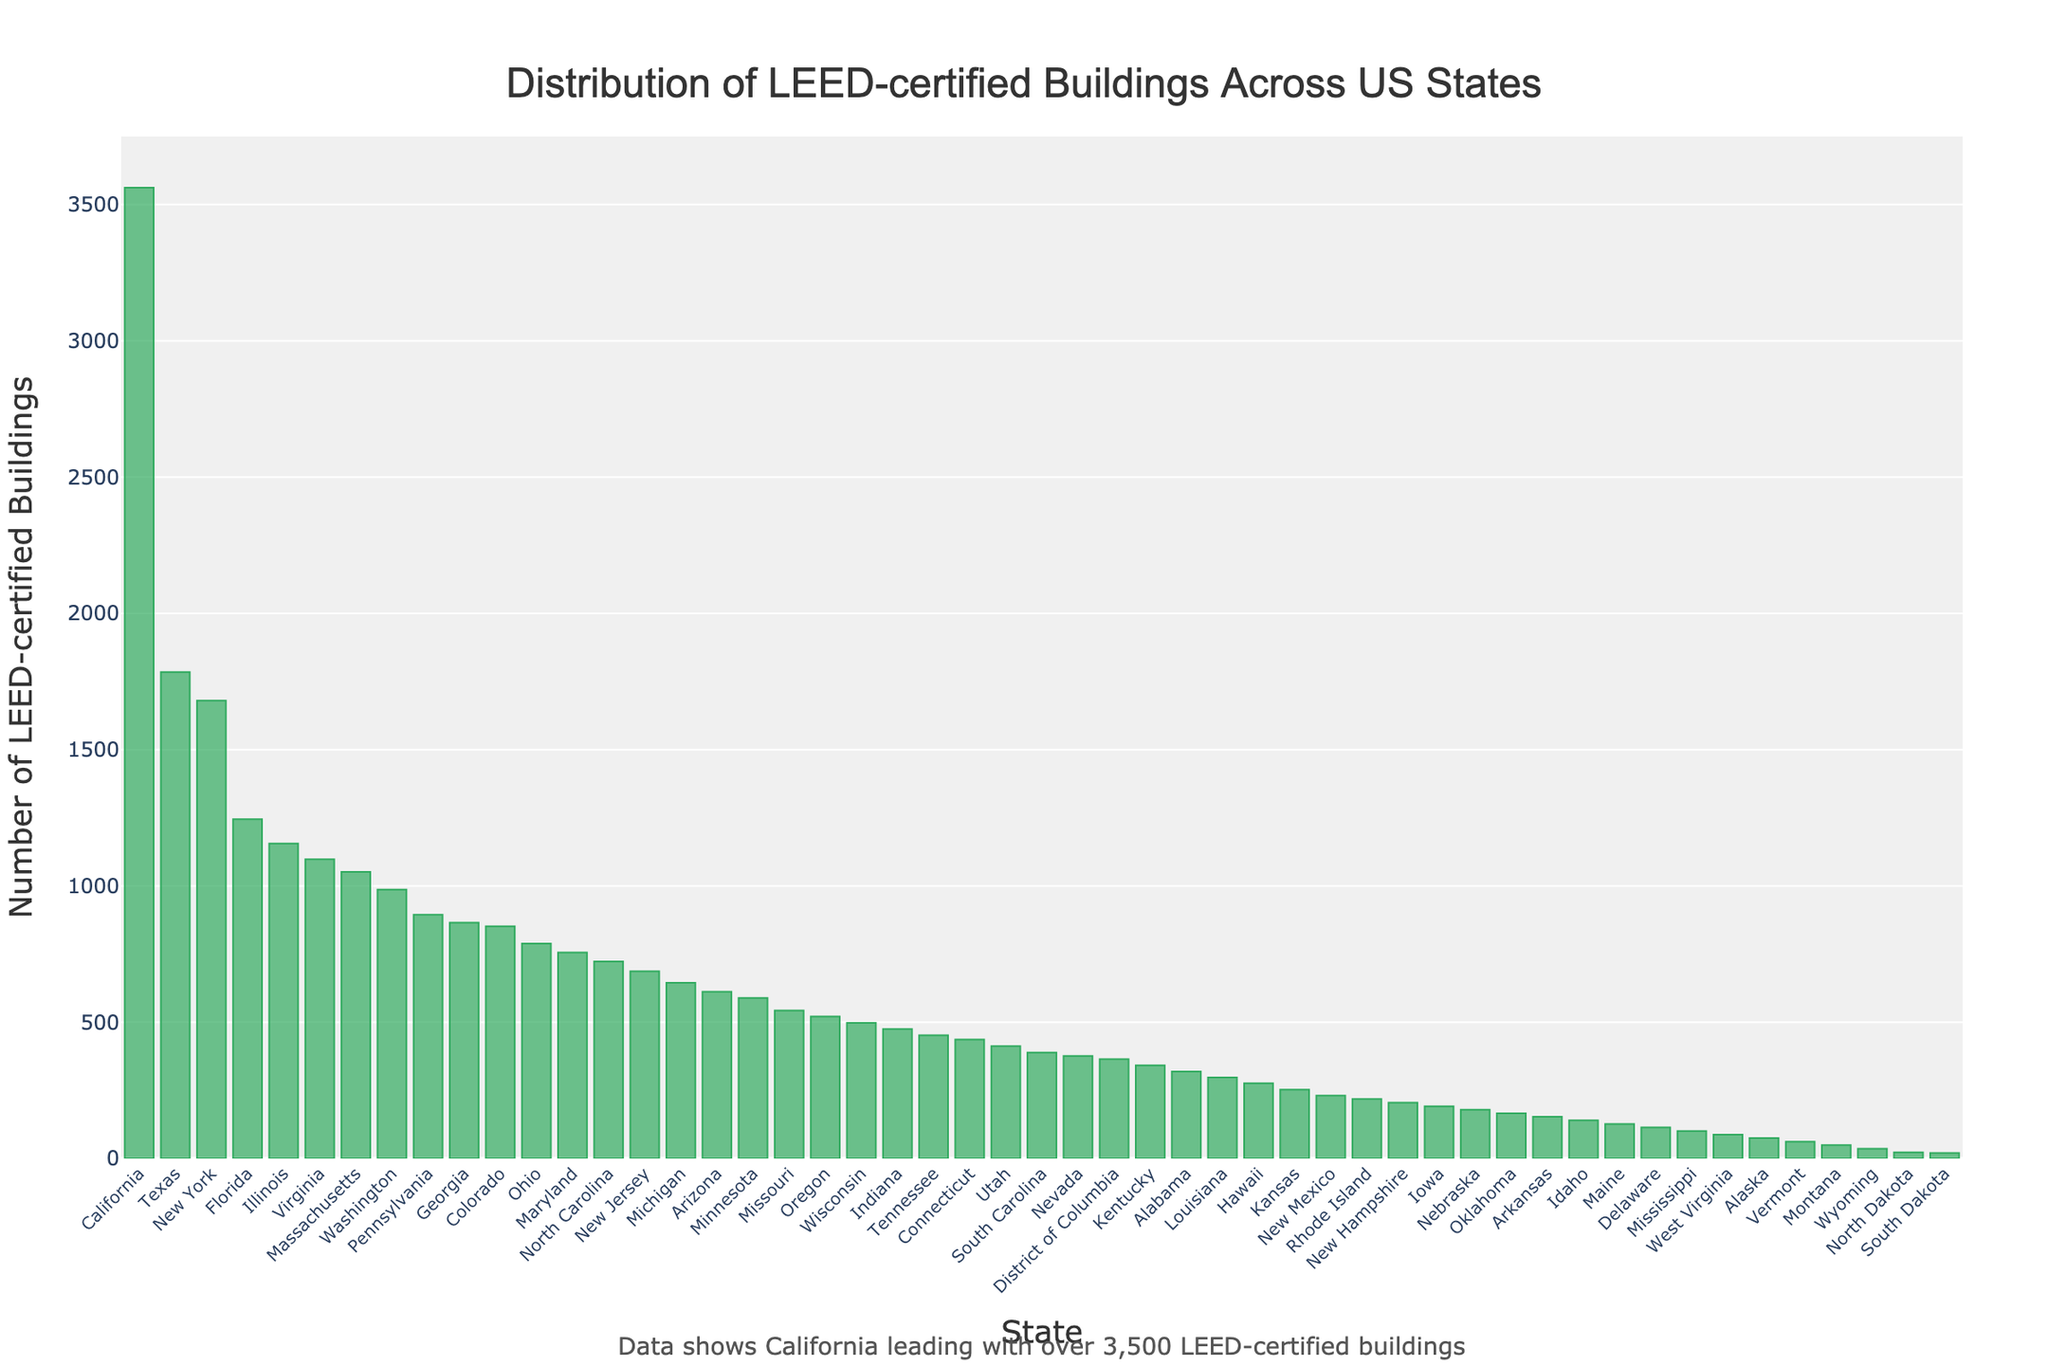Which state has the highest number of LEED-certified buildings? The bar chart shows the number of LEED-certified buildings for each state. By observation, California has the tallest bar, indicating it has the most LEED-certified buildings.
Answer: California Which state has more LEED-certified buildings, New York or Texas? Comparing the heights of the bars for New York and Texas, Texas has a taller bar than New York, which means Texas has more LEED-certified buildings.
Answer: Texas What is the total number of LEED-certified buildings in the top three states? The numbers of LEED-certified buildings in the top three states are: California (3562), Texas (1785), and New York (1680). Summing these values gives 3562 + 1785 + 1680 = 7027.
Answer: 7027 Which state has the least number of LEED-certified buildings, and what is that number? The bar chart shows that Wyoming has the shortest bar, indicating it has the least number of LEED-certified buildings, which is 36.
Answer: Wyoming, 36 How many states have over 1000 LEED-certified buildings? Counting the states with bars representing over 1000 LEED-certified buildings are: California, Texas, New York, Florida, Illinois, Virginia, Massachusetts, and Washington. This gives a total of 8 states.
Answer: 8 Which state has more LEED-certified buildings, Oregon or Pennsylvania? By observing the heights of the bars for Oregon and Pennsylvania, Pennsylvania has a taller bar than Oregon, indicating Pennsylvania has more LEED-certified buildings.
Answer: Pennsylvania What is the difference in the number of LEED-certified buildings between Florida and Illinois? The bar chart shows Florida has 1245 LEED-certified buildings, while Illinois has 1156. The difference is 1245 - 1156 = 89.
Answer: 89 How many LEED-certified buildings do Arizona and Colorado have when combined? The bar chart shows Arizona with 612 buildings and Colorado with 852 buildings. Adding these together gives 612 + 852 = 1464.
Answer: 1464 What is the average number of LEED-certified buildings among California, Texas, and New York? Adding the numbers for California (3562), Texas (1785), and New York (1680) gives 3562 + 1785 + 1680 = 7027. Dividing by 3 for the average: 7027 / 3 = 2342.33.
Answer: 2342.33 Is the number of LEED-certified buildings in Indiana greater than or equal to 500? Observing the bar for Indiana, it shows 475 buildings, which is less than 500.
Answer: No 